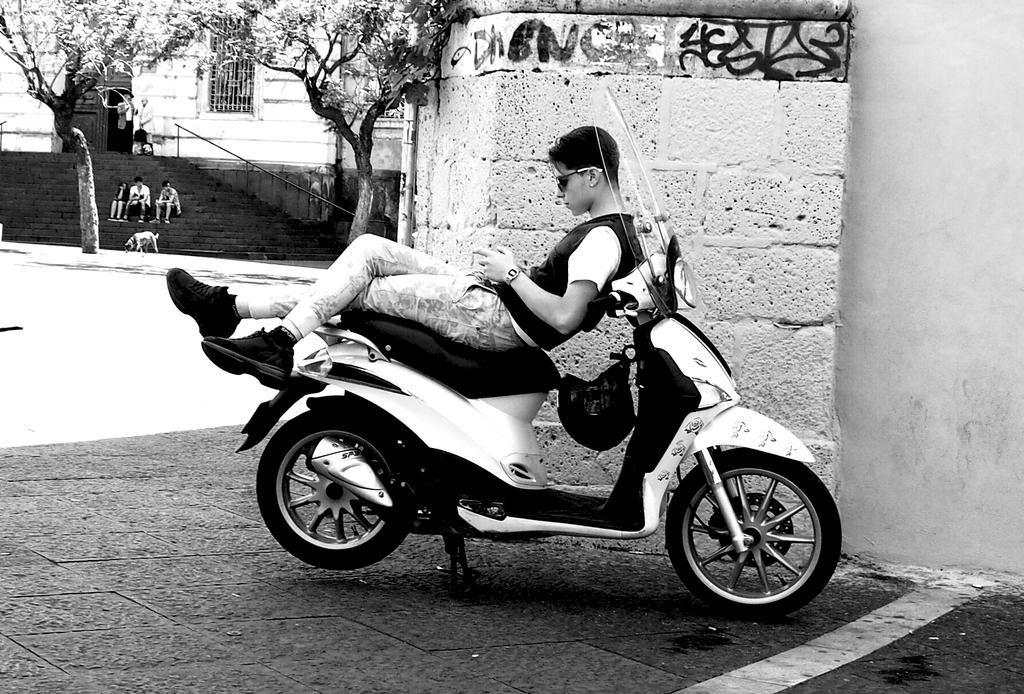What is the man in the image doing? The man is laying on the seat of a motorcycle. What can be seen in the background of the image? There are trees and a building visible in the image. Are there any animals present in the image? Yes, there is a dog in the image. How many people are seated on the stairs in the image? There are three people seated on the stairs in the image. How many buttons are on the dog's collar in the image? There are no buttons mentioned or visible on the dog's collar in the image. What type of stem is growing from the motorcycle in the image? There is no stem growing from the motorcycle in the image. 